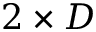Convert formula to latex. <formula><loc_0><loc_0><loc_500><loc_500>2 \times D</formula> 